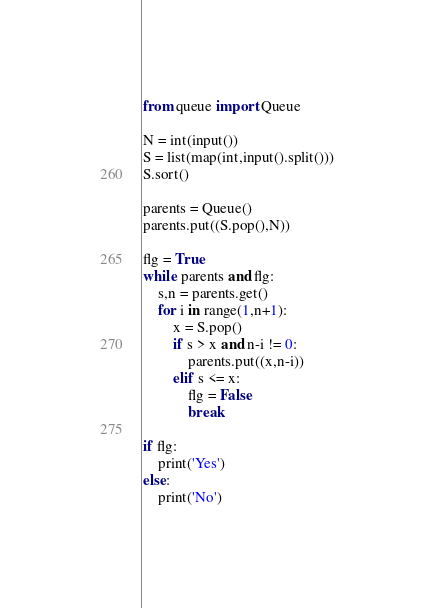Convert code to text. <code><loc_0><loc_0><loc_500><loc_500><_Python_>from queue import Queue

N = int(input())
S = list(map(int,input().split()))
S.sort()

parents = Queue()
parents.put((S.pop(),N))

flg = True
while parents and flg:
    s,n = parents.get()
    for i in range(1,n+1):
        x = S.pop()
        if s > x and n-i != 0:
            parents.put((x,n-i))
        elif s <= x:
            flg = False
            break
 
if flg:
    print('Yes')
else:
    print('No')</code> 